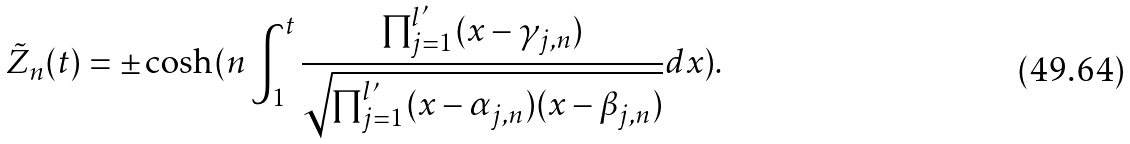<formula> <loc_0><loc_0><loc_500><loc_500>\tilde { Z } _ { n } ( t ) = \pm \cosh ( n \int _ { 1 } ^ { t } \frac { \prod _ { j = 1 } ^ { l ^ { \prime } } ( x - \gamma _ { j , n } ) } { \sqrt { \prod _ { j = 1 } ^ { l ^ { \prime } } ( x - \alpha _ { j , n } ) ( x - \beta _ { j , n } ) } } d x ) .</formula> 